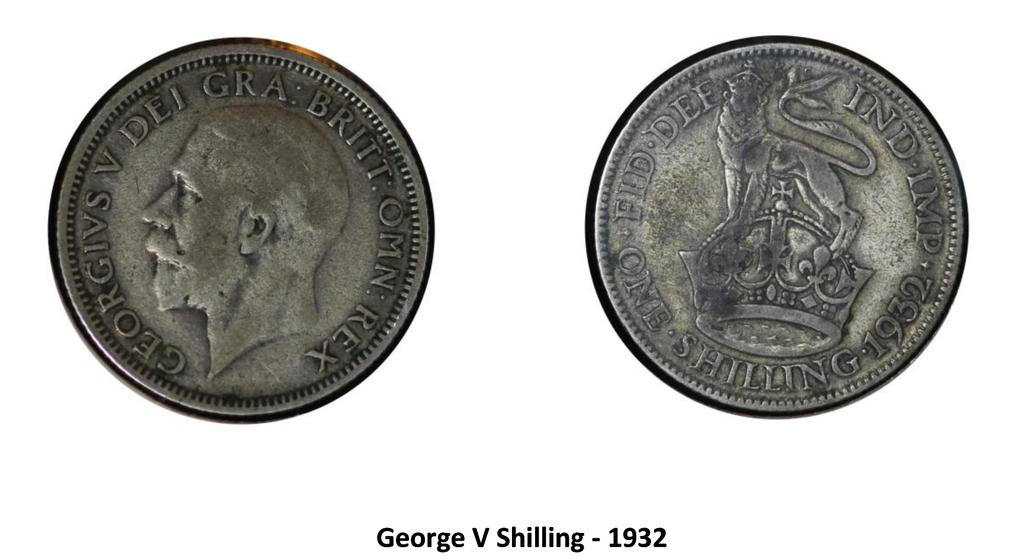<image>
Render a clear and concise summary of the photo. The coin that is displayed from the front and back is a George V Shilling from 1932. 